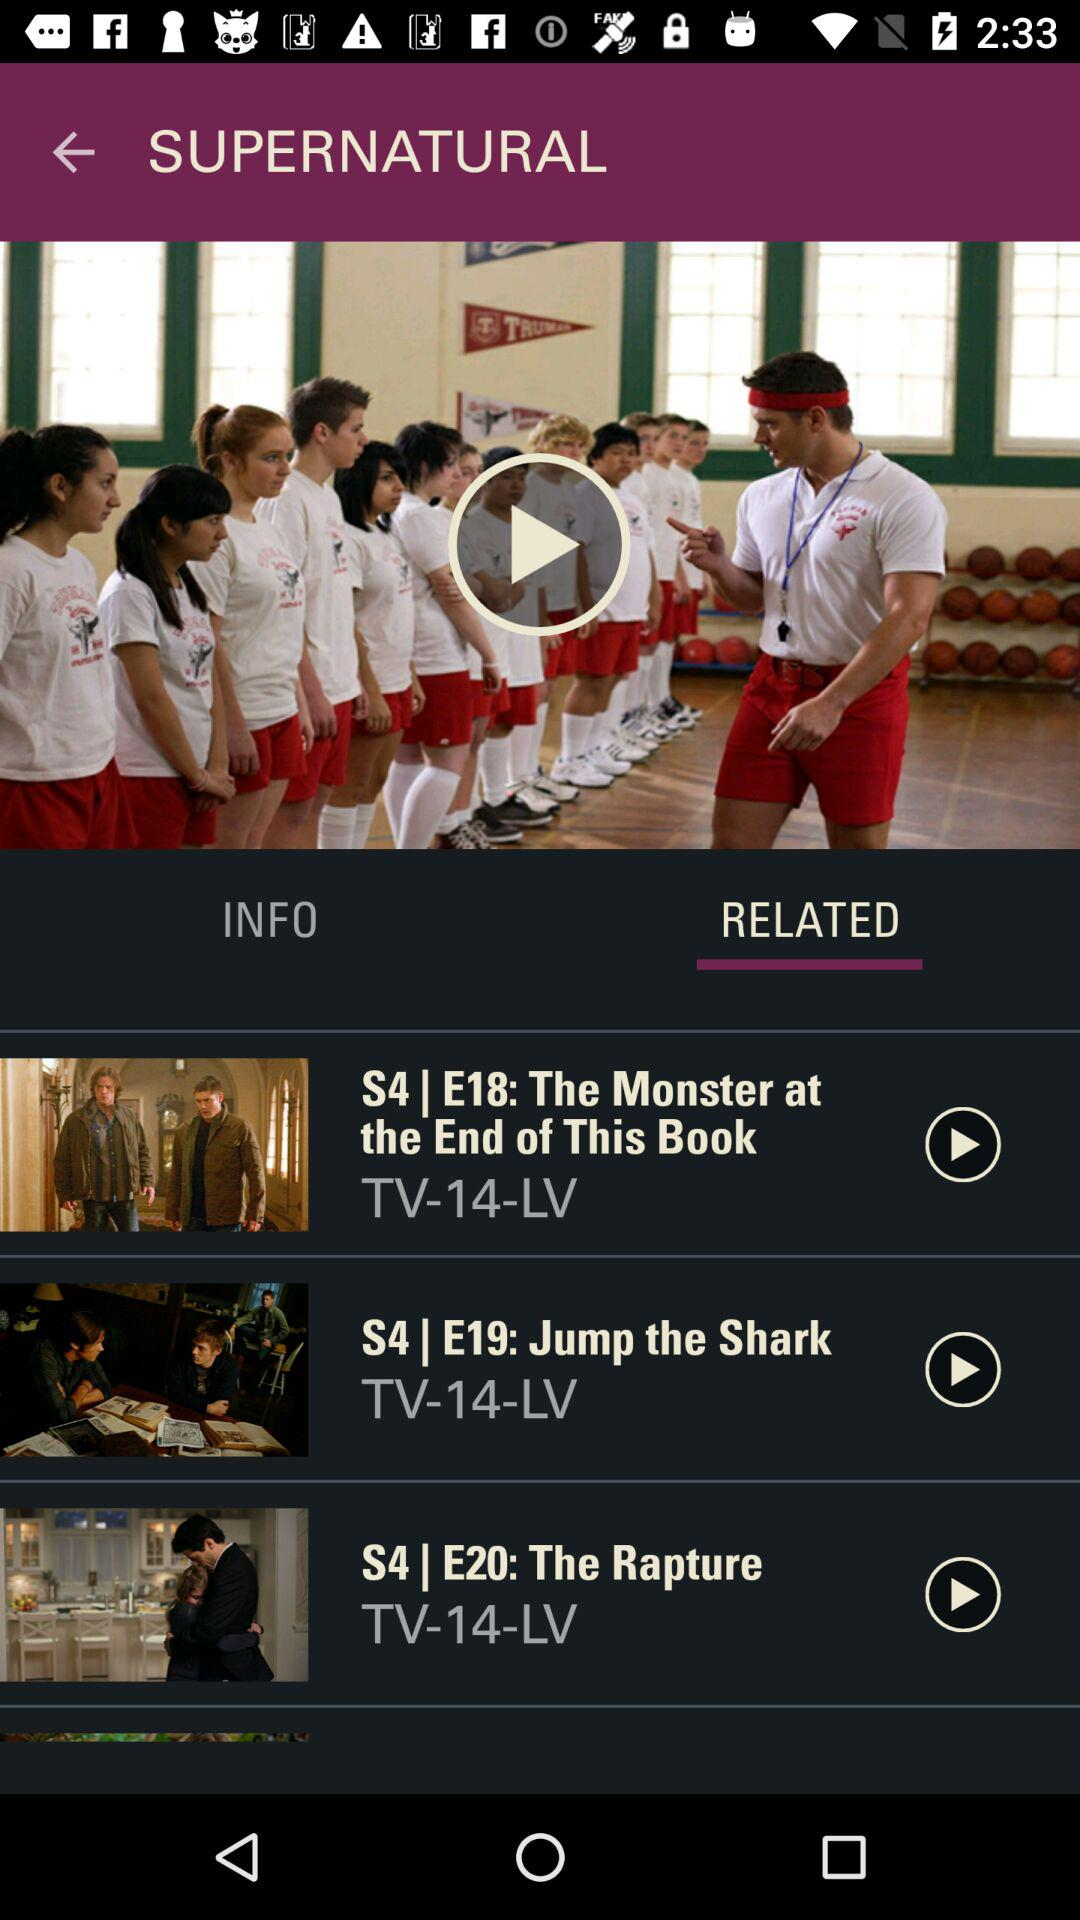What is the selected option? The selected option is "RELATED". 